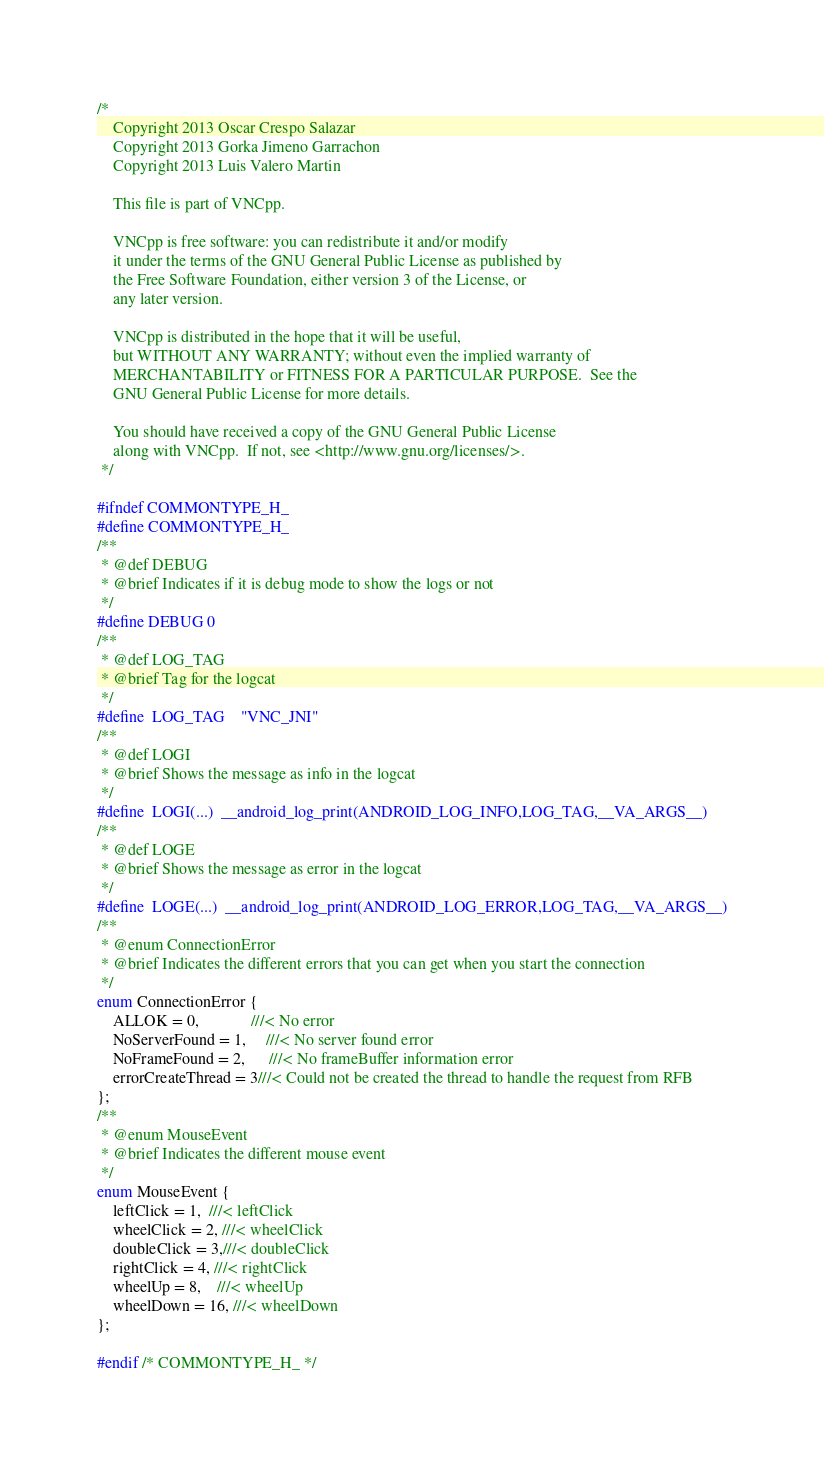<code> <loc_0><loc_0><loc_500><loc_500><_C_>/*
 	Copyright 2013 Oscar Crespo Salazar
 	Copyright 2013 Gorka Jimeno Garrachon
 	Copyright 2013 Luis Valero Martin

	This file is part of VNCpp.

	VNCpp is free software: you can redistribute it and/or modify
	it under the terms of the GNU General Public License as published by
	the Free Software Foundation, either version 3 of the License, or
	any later version.

	VNCpp is distributed in the hope that it will be useful,
	but WITHOUT ANY WARRANTY; without even the implied warranty of
	MERCHANTABILITY or FITNESS FOR A PARTICULAR PURPOSE.  See the
	GNU General Public License for more details.

	You should have received a copy of the GNU General Public License
	along with VNCpp.  If not, see <http://www.gnu.org/licenses/>.
 */

#ifndef COMMONTYPE_H_
#define COMMONTYPE_H_
/**
 * @def DEBUG
 * @brief Indicates if it is debug mode to show the logs or not
 */
#define DEBUG 0
/**
 * @def LOG_TAG
 * @brief Tag for the logcat
 */
#define  LOG_TAG    "VNC_JNI"
/**
 * @def LOGI
 * @brief Shows the message as info in the logcat
 */
#define  LOGI(...)  __android_log_print(ANDROID_LOG_INFO,LOG_TAG,__VA_ARGS__)
/**
 * @def LOGE
 * @brief Shows the message as error in the logcat
 */
#define  LOGE(...)  __android_log_print(ANDROID_LOG_ERROR,LOG_TAG,__VA_ARGS__)
/**
 * @enum ConnectionError
 * @brief Indicates the different errors that you can get when you start the connection
 */
enum ConnectionError {
    ALLOK = 0,             ///< No error
    NoServerFound = 1,     ///< No server found error
    NoFrameFound = 2,      ///< No frameBuffer information error
    errorCreateThread = 3///< Could not be created the thread to handle the request from RFB
};
/**
 * @enum MouseEvent
 * @brief Indicates the different mouse event
 */
enum MouseEvent {
    leftClick = 1,  ///< leftClick
    wheelClick = 2, ///< wheelClick
    doubleClick = 3,///< doubleClick
    rightClick = 4, ///< rightClick
    wheelUp = 8,    ///< wheelUp
    wheelDown = 16, ///< wheelDown
};

#endif /* COMMONTYPE_H_ */
</code> 